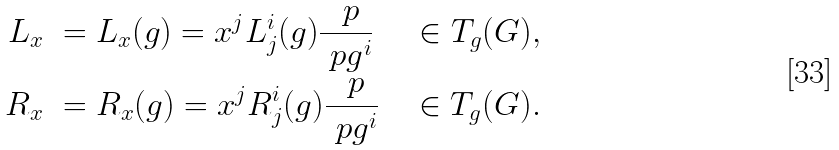<formula> <loc_0><loc_0><loc_500><loc_500>L _ { x } & \ = L _ { x } ( g ) = x ^ { j } L ^ { i } _ { j } ( g ) \frac { \ p } { \ p g ^ { i } } \quad \, \in T _ { g } ( G ) , \\ R _ { x } & \ = R _ { x } ( g ) = x ^ { j } R ^ { i } _ { j } ( g ) \frac { \ p } { \ p g ^ { i } } \quad \in T _ { g } ( G ) .</formula> 